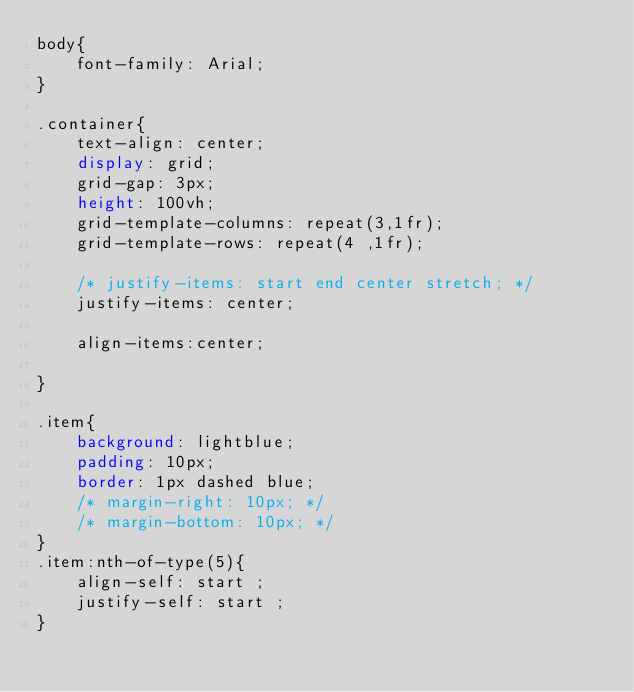Convert code to text. <code><loc_0><loc_0><loc_500><loc_500><_CSS_>body{
    font-family: Arial;
}

.container{
    text-align: center;
    display: grid;
    grid-gap: 3px;
    height: 100vh;
    grid-template-columns: repeat(3,1fr);
    grid-template-rows: repeat(4 ,1fr);

    /* justify-items: start end center stretch; */
    justify-items: center;

    align-items:center;

}

.item{
    background: lightblue;
    padding: 10px;
    border: 1px dashed blue;
    /* margin-right: 10px; */
    /* margin-bottom: 10px; */
}
.item:nth-of-type(5){
    align-self: start ;
    justify-self: start ;
}

</code> 